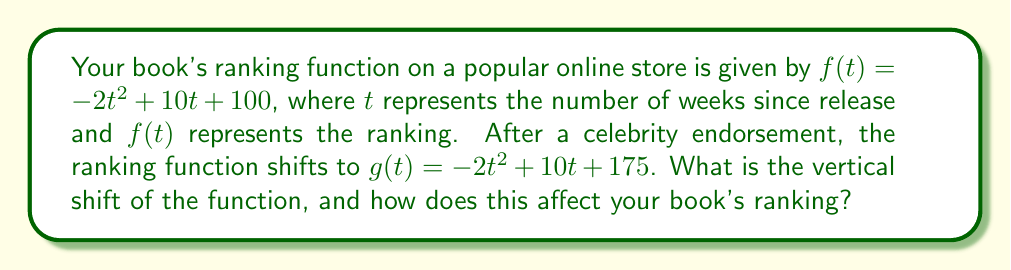Solve this math problem. To find the vertical shift between functions $f(t)$ and $g(t)$, we need to compare their constant terms:

1) The original function: $f(t) = -2t^2 + 10t + 100$
2) The new function after endorsement: $g(t) = -2t^2 + 10t + 175$

3) The vertical shift is the difference between the constant terms:
   $175 - 100 = 75$

4) This means the function has shifted 75 units upward.

5) In the context of rankings, a higher number typically indicates a worse ranking. Therefore, an upward shift in the function actually represents an improvement in the book's ranking.

6) The book's ranking has improved by 75 positions at every point in time compared to its original ranking function.
Answer: 75 units upward; improves ranking by 75 positions 